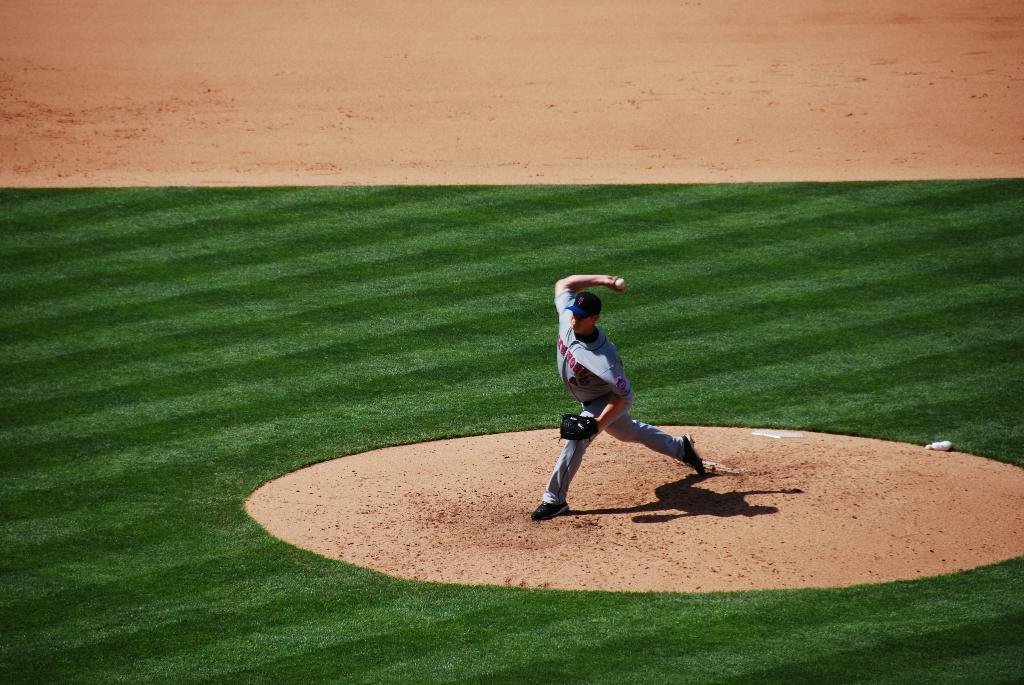What is the main subject of the image? There is a baseball player in the image. What is the baseball player doing? The baseball player is standing on the ground and throwing a ball. What can be seen in the background of the image? There is sand in the background of the image. What type of surface is the baseball player standing on? There is grass on the ground in the image. What type of apparel is the baseball player wearing to improve the acoustics in the image? There is no mention of apparel or acoustics in the image. Additionally, apparel does not typically affect acoustics. Can you see any cattle in the image? There are no cattle present in the image. 